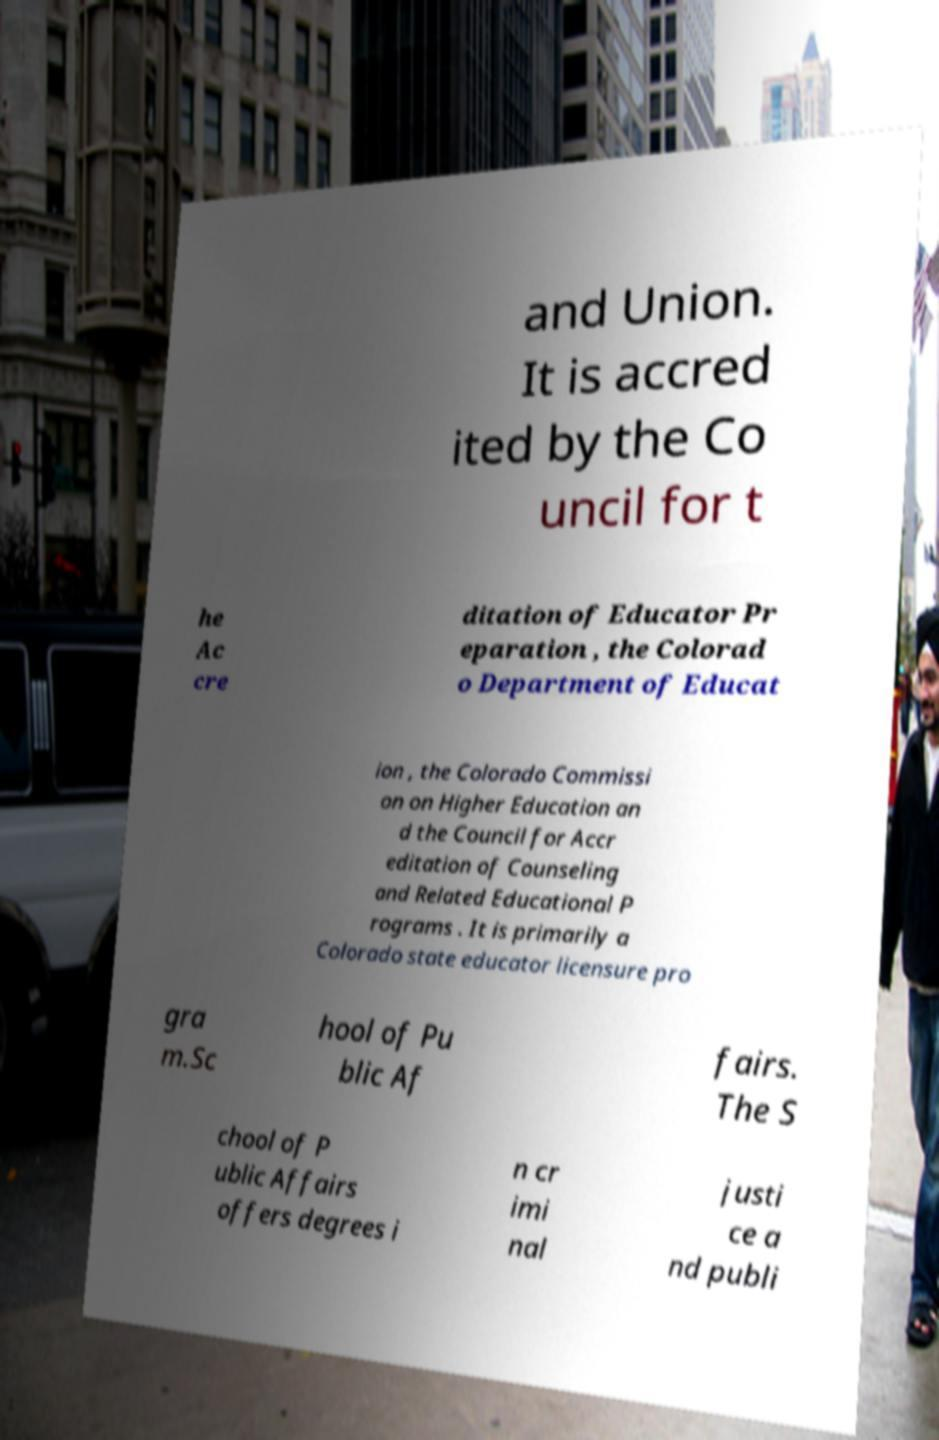There's text embedded in this image that I need extracted. Can you transcribe it verbatim? and Union. It is accred ited by the Co uncil for t he Ac cre ditation of Educator Pr eparation , the Colorad o Department of Educat ion , the Colorado Commissi on on Higher Education an d the Council for Accr editation of Counseling and Related Educational P rograms . It is primarily a Colorado state educator licensure pro gra m.Sc hool of Pu blic Af fairs. The S chool of P ublic Affairs offers degrees i n cr imi nal justi ce a nd publi 